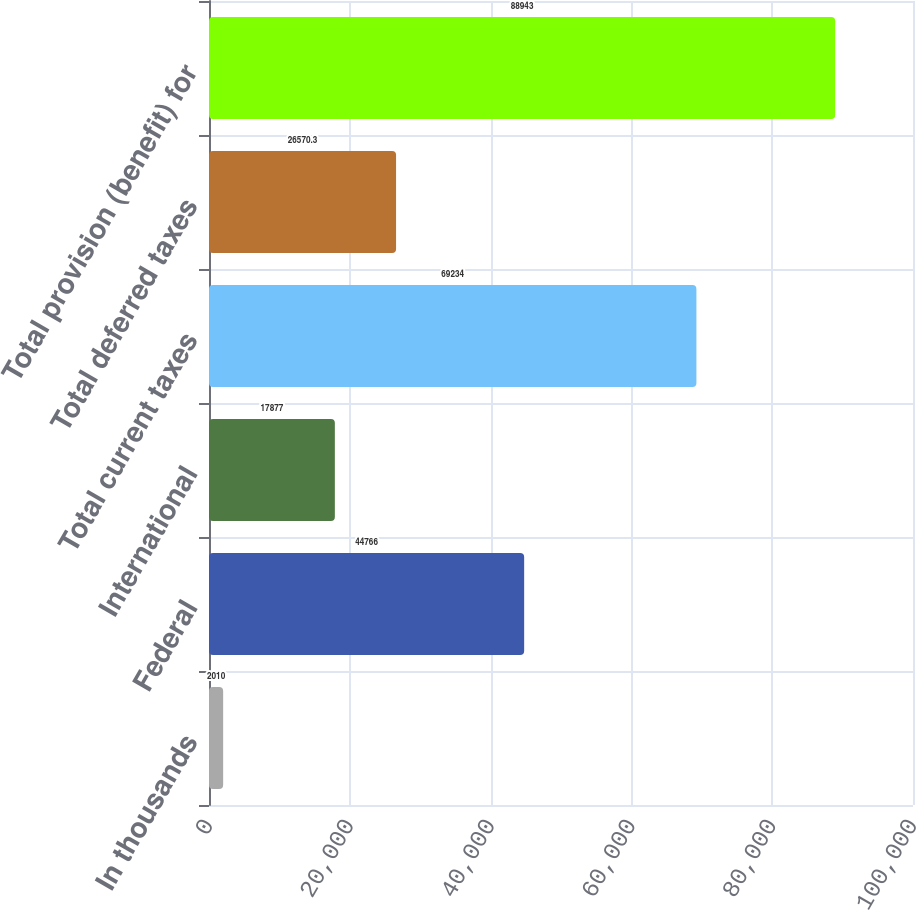<chart> <loc_0><loc_0><loc_500><loc_500><bar_chart><fcel>In thousands<fcel>Federal<fcel>International<fcel>Total current taxes<fcel>Total deferred taxes<fcel>Total provision (benefit) for<nl><fcel>2010<fcel>44766<fcel>17877<fcel>69234<fcel>26570.3<fcel>88943<nl></chart> 